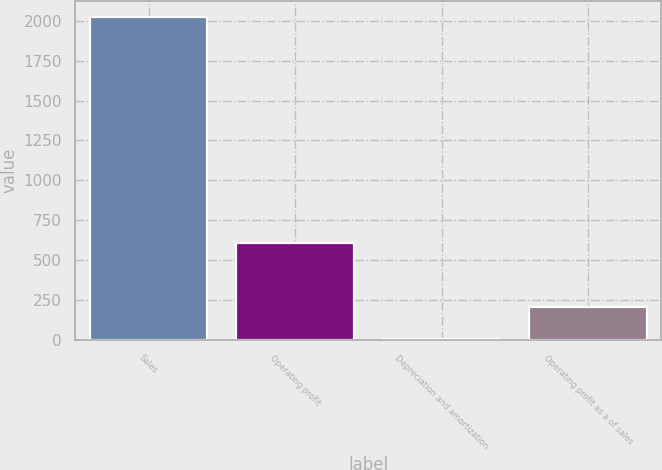Convert chart. <chart><loc_0><loc_0><loc_500><loc_500><bar_chart><fcel>Sales<fcel>Operating profit<fcel>Depreciation and amortization<fcel>Operating profit as a of sales<nl><fcel>2022.9<fcel>610.09<fcel>4.6<fcel>206.43<nl></chart> 